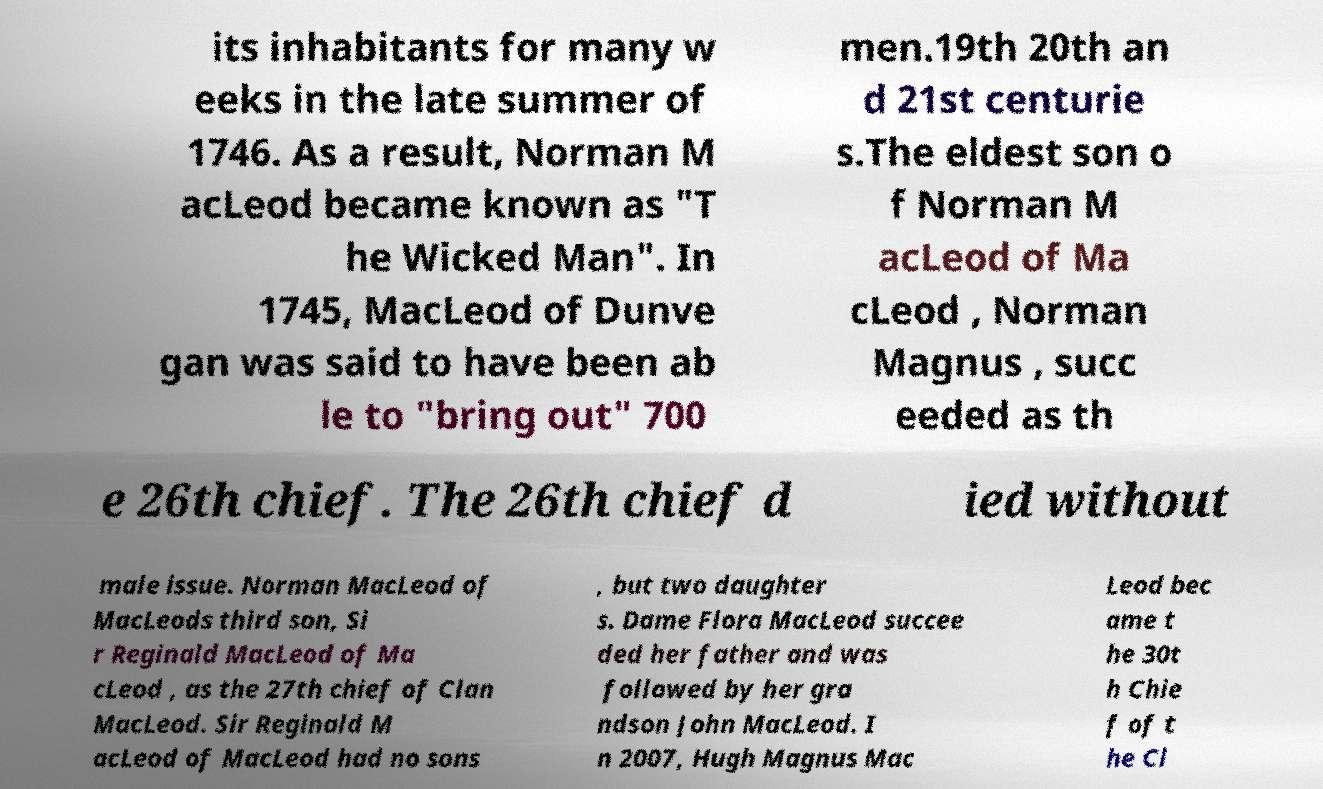Please read and relay the text visible in this image. What does it say? its inhabitants for many w eeks in the late summer of 1746. As a result, Norman M acLeod became known as "T he Wicked Man". In 1745, MacLeod of Dunve gan was said to have been ab le to "bring out" 700 men.19th 20th an d 21st centurie s.The eldest son o f Norman M acLeod of Ma cLeod , Norman Magnus , succ eeded as th e 26th chief. The 26th chief d ied without male issue. Norman MacLeod of MacLeods third son, Si r Reginald MacLeod of Ma cLeod , as the 27th chief of Clan MacLeod. Sir Reginald M acLeod of MacLeod had no sons , but two daughter s. Dame Flora MacLeod succee ded her father and was followed by her gra ndson John MacLeod. I n 2007, Hugh Magnus Mac Leod bec ame t he 30t h Chie f of t he Cl 